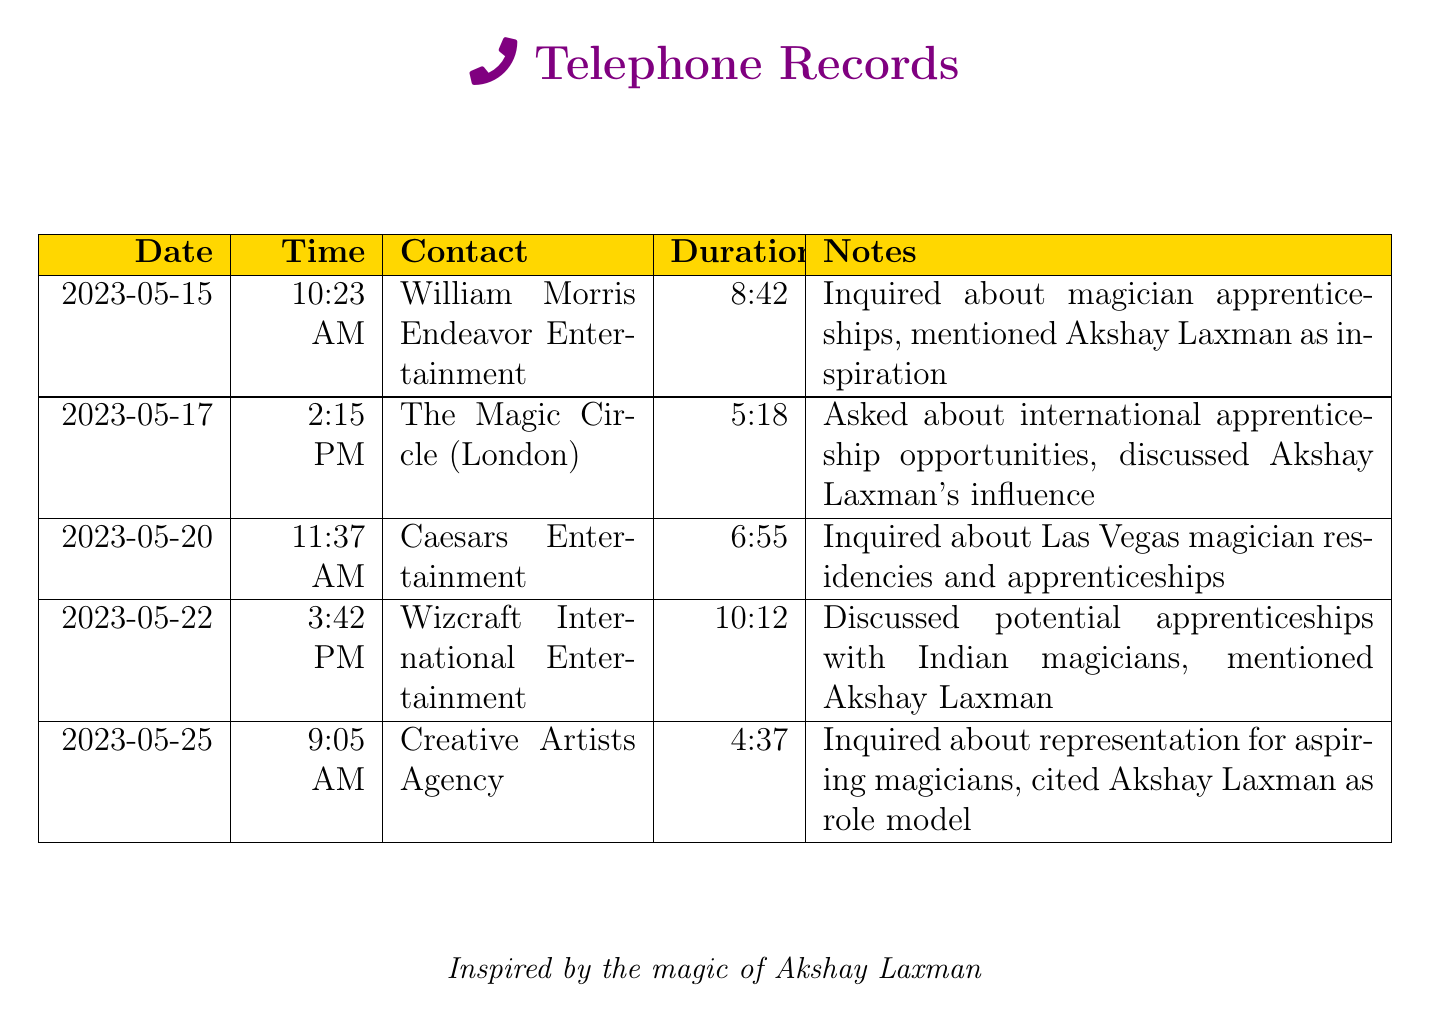What date was the call to William Morris Endeavor Entertainment? The call to William Morris Endeavor Entertainment was made on 2023-05-15.
Answer: 2023-05-15 How long was the longest call recorded? The longest call recorded was to Wizcraft International Entertainment for 10 minutes and 12 seconds.
Answer: 10:12 What agency was contacted on May 25? The agency contacted on May 25 was Creative Artists Agency.
Answer: Creative Artists Agency How many calls involved a mention of Akshay Laxman? There were four calls where Akshay Laxman was mentioned.
Answer: Four What time did the call to The Magic Circle occur? The call to The Magic Circle occurred at 2:15 PM.
Answer: 2:15 PM Which agency was associated with Las Vegas magician residencies? Caesars Entertainment was the agency associated with Las Vegas magician residencies.
Answer: Caesars Entertainment What type of opportunities were inquired about during the call to The Magic Circle? International apprenticeship opportunities were inquired about during the call to The Magic Circle.
Answer: International apprenticeship opportunities What was the primary topic of discussion during the call to Wizcraft International Entertainment? The primary topic of discussion was potential apprenticeships with Indian magicians.
Answer: Potential apprenticeships with Indian magicians 